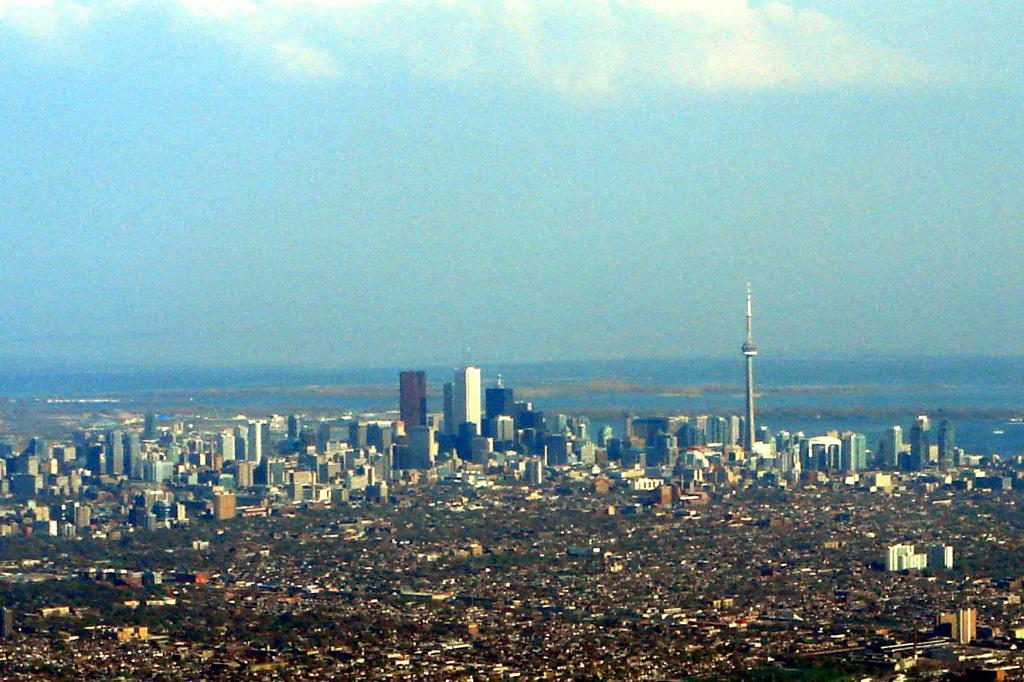What is visible at the top of the image? The sky is visible at the top of the image. What can be seen in the sky? There are clouds in the sky. What type of structures are present in the image? There are buildings, skyscrapers, and a tower in the image. What type of vegetation is present in the image? There are trees in the image. What type of celery is being used as a health supplement in the image? There is no celery or health supplements present in the image. What fictional character can be seen interacting with the skyscrapers in the image? There are no fictional characters present in the image; it features real-life structures such as buildings, skyscrapers, and a tower. 